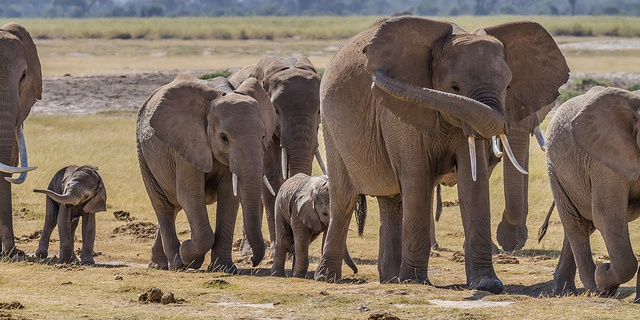Describe the objects in this image and their specific colors. I can see elephant in gray, black, and maroon tones, elephant in gray, black, and maroon tones, elephant in gray, maroon, and black tones, elephant in gray, black, and darkgray tones, and elephant in gray, black, and maroon tones in this image. 